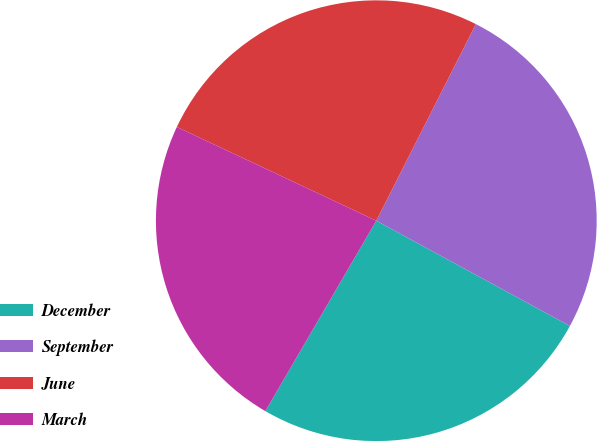<chart> <loc_0><loc_0><loc_500><loc_500><pie_chart><fcel>December<fcel>September<fcel>June<fcel>March<nl><fcel>25.47%<fcel>25.47%<fcel>25.47%<fcel>23.6%<nl></chart> 